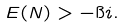Convert formula to latex. <formula><loc_0><loc_0><loc_500><loc_500>E ( N ) > - \i i .</formula> 